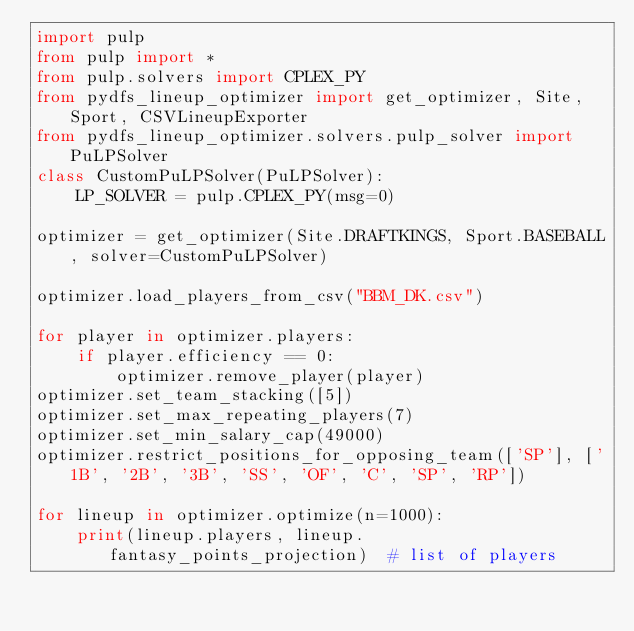<code> <loc_0><loc_0><loc_500><loc_500><_Python_>import pulp
from pulp import *
from pulp.solvers import CPLEX_PY
from pydfs_lineup_optimizer import get_optimizer, Site, Sport, CSVLineupExporter
from pydfs_lineup_optimizer.solvers.pulp_solver import PuLPSolver
class CustomPuLPSolver(PuLPSolver):
    LP_SOLVER = pulp.CPLEX_PY(msg=0)

optimizer = get_optimizer(Site.DRAFTKINGS, Sport.BASEBALL, solver=CustomPuLPSolver)

optimizer.load_players_from_csv("BBM_DK.csv")

for player in optimizer.players:
    if player.efficiency == 0:
        optimizer.remove_player(player)
optimizer.set_team_stacking([5])
optimizer.set_max_repeating_players(7)
optimizer.set_min_salary_cap(49000)
optimizer.restrict_positions_for_opposing_team(['SP'], ['1B', '2B', '3B', 'SS', 'OF', 'C', 'SP', 'RP'])

for lineup in optimizer.optimize(n=1000):
    print(lineup.players, lineup.fantasy_points_projection)  # list of players</code> 